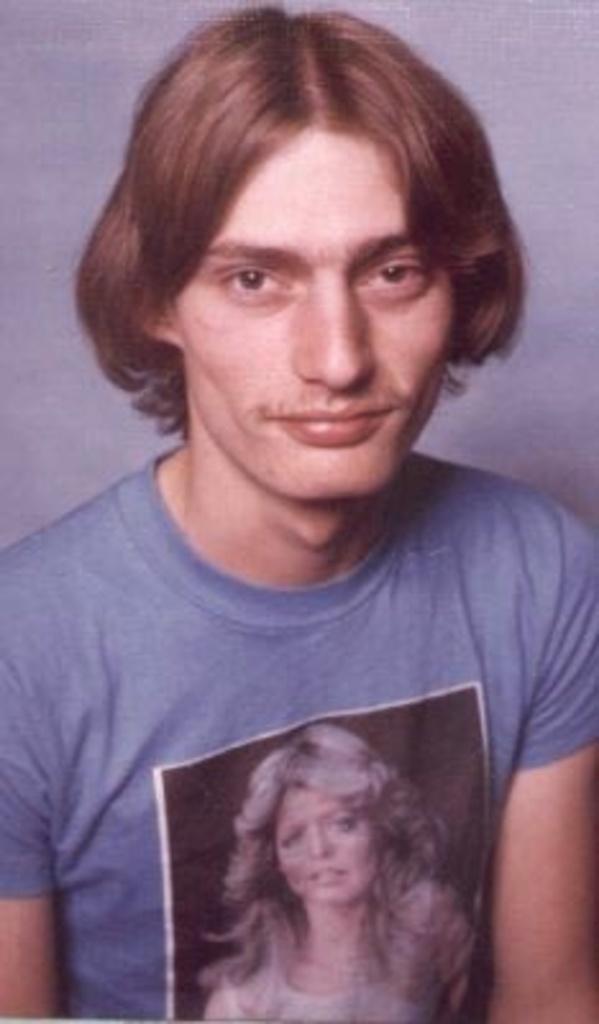Could you give a brief overview of what you see in this image? In the picture I can see a man is wearing a T-shirt. On the T-shirt I can see a photo of a woman. 